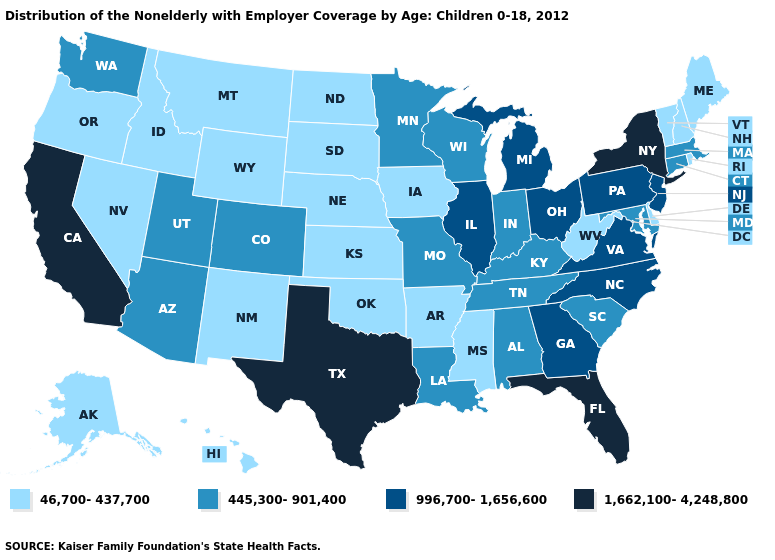What is the highest value in the USA?
Write a very short answer. 1,662,100-4,248,800. What is the value of New York?
Quick response, please. 1,662,100-4,248,800. Name the states that have a value in the range 445,300-901,400?
Be succinct. Alabama, Arizona, Colorado, Connecticut, Indiana, Kentucky, Louisiana, Maryland, Massachusetts, Minnesota, Missouri, South Carolina, Tennessee, Utah, Washington, Wisconsin. Does the first symbol in the legend represent the smallest category?
Quick response, please. Yes. Does New York have the highest value in the Northeast?
Give a very brief answer. Yes. Name the states that have a value in the range 1,662,100-4,248,800?
Short answer required. California, Florida, New York, Texas. Name the states that have a value in the range 445,300-901,400?
Be succinct. Alabama, Arizona, Colorado, Connecticut, Indiana, Kentucky, Louisiana, Maryland, Massachusetts, Minnesota, Missouri, South Carolina, Tennessee, Utah, Washington, Wisconsin. Does the map have missing data?
Be succinct. No. What is the value of Indiana?
Write a very short answer. 445,300-901,400. Which states hav the highest value in the South?
Answer briefly. Florida, Texas. Which states have the lowest value in the USA?
Be succinct. Alaska, Arkansas, Delaware, Hawaii, Idaho, Iowa, Kansas, Maine, Mississippi, Montana, Nebraska, Nevada, New Hampshire, New Mexico, North Dakota, Oklahoma, Oregon, Rhode Island, South Dakota, Vermont, West Virginia, Wyoming. Name the states that have a value in the range 445,300-901,400?
Write a very short answer. Alabama, Arizona, Colorado, Connecticut, Indiana, Kentucky, Louisiana, Maryland, Massachusetts, Minnesota, Missouri, South Carolina, Tennessee, Utah, Washington, Wisconsin. Does the map have missing data?
Write a very short answer. No. 